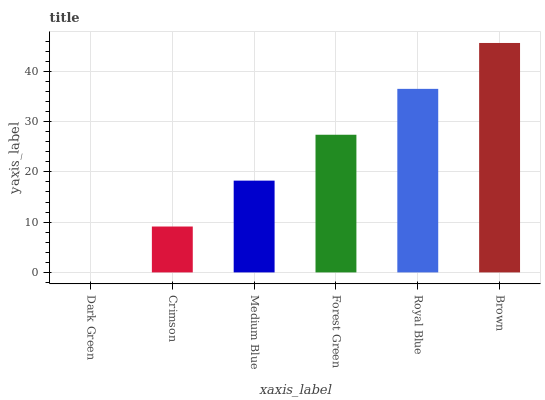Is Dark Green the minimum?
Answer yes or no. Yes. Is Brown the maximum?
Answer yes or no. Yes. Is Crimson the minimum?
Answer yes or no. No. Is Crimson the maximum?
Answer yes or no. No. Is Crimson greater than Dark Green?
Answer yes or no. Yes. Is Dark Green less than Crimson?
Answer yes or no. Yes. Is Dark Green greater than Crimson?
Answer yes or no. No. Is Crimson less than Dark Green?
Answer yes or no. No. Is Forest Green the high median?
Answer yes or no. Yes. Is Medium Blue the low median?
Answer yes or no. Yes. Is Dark Green the high median?
Answer yes or no. No. Is Dark Green the low median?
Answer yes or no. No. 